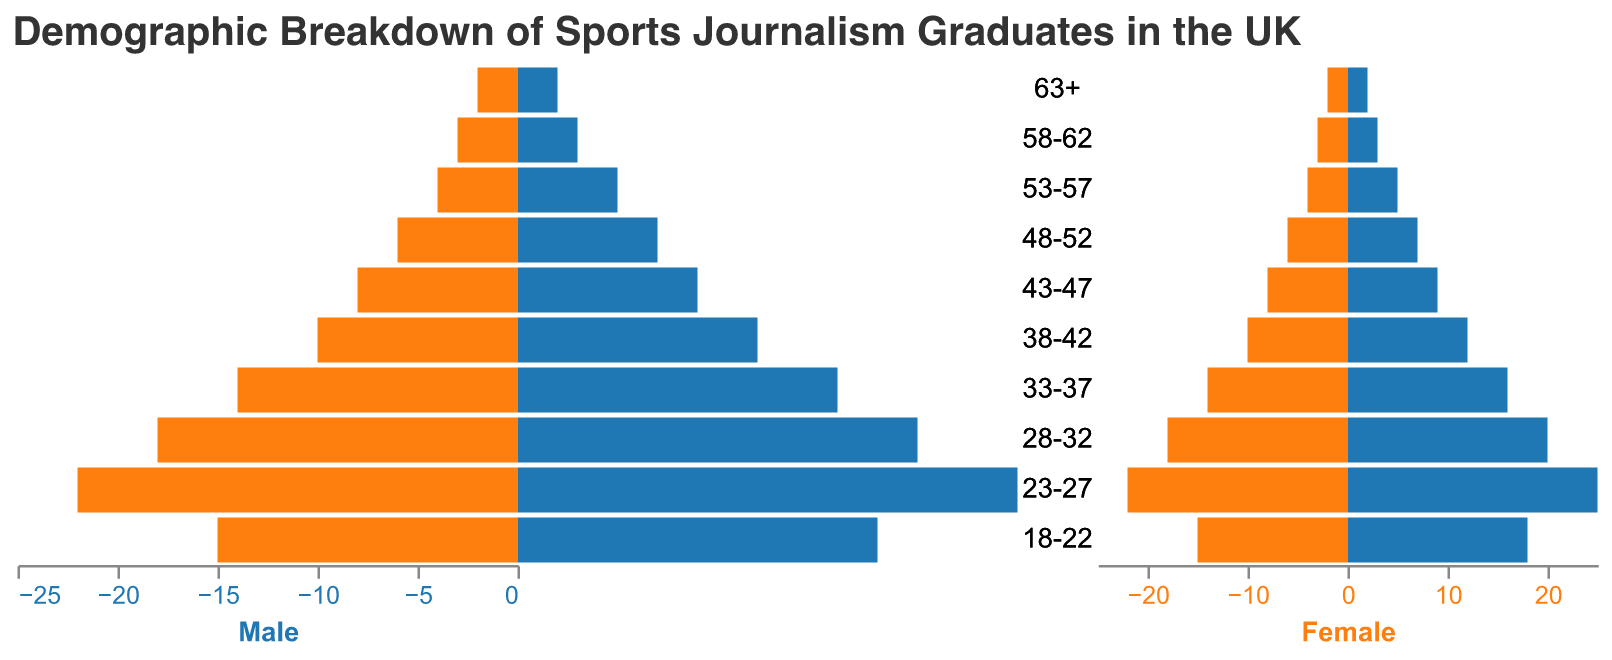What is the title of the figure? The title of the figure is usually located at the top. In this case, the provided code specifies the title as "Demographic Breakdown of Sports Journalism Graduates in the UK."
Answer: Demographic Breakdown of Sports Journalism Graduates in the UK Which age group has the highest number of female graduates? By examining the "Female" bar chart, we see that the age group with the largest bar is "23-27," which indicates the highest number, 25.
Answer: 23-27 What is the combined total number of graduates aged 18-22? For the 18-22 age group, add the number of male (15) and female (18) graduates: 15 + 18 = 33.
Answer: 33 How many age groups have more male graduates compared to female graduates? Compare the male and female values in each age group. No age group has more males than females in the given data.
Answer: 0 Which age group has the smallest difference in the number of male and female graduates? Calculate the absolute difference for each age group: 18-22 (3), 23-27 (3), 28-32 (2), 33-37 (2), 38-42 (2), 43-47 (1), 48-52 (1), 53-57 (1), 58-62 (0), 63+ (0). The smallest differences are in the 58-62 and 63+ groups with a difference of 0.
Answer: 58-62, 63+ Which age group has exactly double the number of female graduates compared to male graduates? None of the age groups have exactly double the number of female graduates compared to male graduates.
Answer: None What is the total number of graduates aged 53 and above? Add all graduates aged 53 and above: 53-57 (4+5=9), 58-62 (3+3=6), 63+ (2+2=4). Total: 9 + 6 + 4 = 19.
Answer: 19 How many age groups have less than 10 male graduates? The age groups with less than 10 male graduates are 43-47 (8), 48-52 (6), 53-57 (4), 58-62 (3), and 63+ (2). Total: 5 age groups.
Answer: 5 Which age group has the largest number of total graduates aged less than 30? Total graduates for each relevant age group: 18-22 (33), 23-27 (47), 28-32 (38). The age group 23-27 has the highest total: 47.
Answer: 23-27 What is the ratio of male to female graduates in the 38-42 age group? The ratio for the 38-42 age group is calculated by dividing the number of male graduates (10) by the number of female graduates (12), which simplifies to 5:6.
Answer: 5:6 